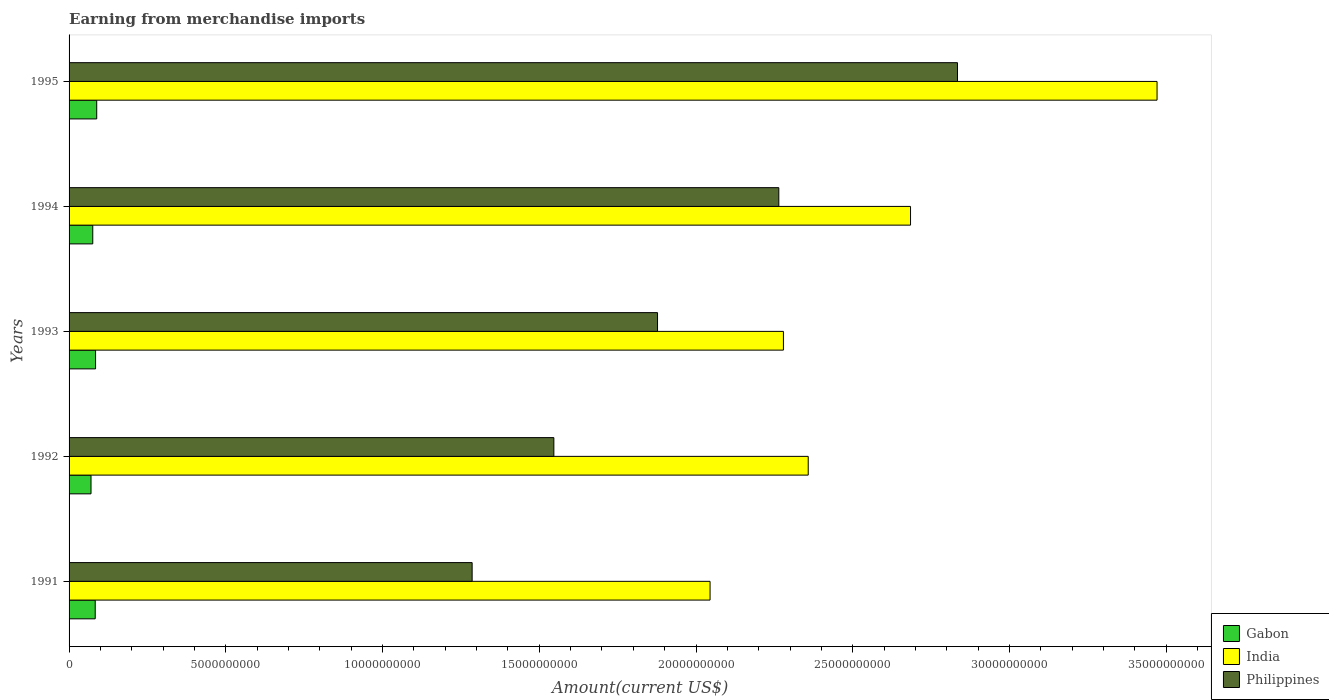How many groups of bars are there?
Your answer should be very brief. 5. Are the number of bars per tick equal to the number of legend labels?
Make the answer very short. Yes. How many bars are there on the 4th tick from the top?
Your answer should be very brief. 3. How many bars are there on the 5th tick from the bottom?
Your answer should be compact. 3. In how many cases, is the number of bars for a given year not equal to the number of legend labels?
Your response must be concise. 0. What is the amount earned from merchandise imports in India in 1992?
Offer a terse response. 2.36e+1. Across all years, what is the maximum amount earned from merchandise imports in Philippines?
Offer a very short reply. 2.83e+1. Across all years, what is the minimum amount earned from merchandise imports in Philippines?
Provide a short and direct response. 1.29e+1. In which year was the amount earned from merchandise imports in Philippines maximum?
Give a very brief answer. 1995. In which year was the amount earned from merchandise imports in India minimum?
Your response must be concise. 1991. What is the total amount earned from merchandise imports in Gabon in the graph?
Provide a short and direct response. 4.02e+09. What is the difference between the amount earned from merchandise imports in Gabon in 1991 and that in 1993?
Offer a very short reply. -1.10e+07. What is the difference between the amount earned from merchandise imports in Philippines in 1994 and the amount earned from merchandise imports in Gabon in 1995?
Your answer should be compact. 2.18e+1. What is the average amount earned from merchandise imports in India per year?
Your response must be concise. 2.57e+1. In the year 1993, what is the difference between the amount earned from merchandise imports in Philippines and amount earned from merchandise imports in India?
Keep it short and to the point. -4.02e+09. What is the ratio of the amount earned from merchandise imports in Philippines in 1994 to that in 1995?
Give a very brief answer. 0.8. Is the amount earned from merchandise imports in Gabon in 1991 less than that in 1992?
Your answer should be compact. No. What is the difference between the highest and the second highest amount earned from merchandise imports in Gabon?
Offer a very short reply. 3.70e+07. What is the difference between the highest and the lowest amount earned from merchandise imports in Gabon?
Your answer should be very brief. 1.82e+08. In how many years, is the amount earned from merchandise imports in India greater than the average amount earned from merchandise imports in India taken over all years?
Your answer should be compact. 2. What does the 1st bar from the bottom in 1993 represents?
Keep it short and to the point. Gabon. How many bars are there?
Give a very brief answer. 15. How many years are there in the graph?
Ensure brevity in your answer.  5. Are the values on the major ticks of X-axis written in scientific E-notation?
Give a very brief answer. No. Does the graph contain grids?
Ensure brevity in your answer.  No. How are the legend labels stacked?
Your answer should be compact. Vertical. What is the title of the graph?
Ensure brevity in your answer.  Earning from merchandise imports. What is the label or title of the X-axis?
Offer a very short reply. Amount(current US$). What is the Amount(current US$) in Gabon in 1991?
Provide a succinct answer. 8.34e+08. What is the Amount(current US$) of India in 1991?
Provide a succinct answer. 2.04e+1. What is the Amount(current US$) of Philippines in 1991?
Offer a terse response. 1.29e+1. What is the Amount(current US$) of Gabon in 1992?
Provide a short and direct response. 7.00e+08. What is the Amount(current US$) in India in 1992?
Keep it short and to the point. 2.36e+1. What is the Amount(current US$) of Philippines in 1992?
Ensure brevity in your answer.  1.55e+1. What is the Amount(current US$) in Gabon in 1993?
Keep it short and to the point. 8.45e+08. What is the Amount(current US$) of India in 1993?
Make the answer very short. 2.28e+1. What is the Amount(current US$) of Philippines in 1993?
Your response must be concise. 1.88e+1. What is the Amount(current US$) of Gabon in 1994?
Give a very brief answer. 7.56e+08. What is the Amount(current US$) of India in 1994?
Offer a terse response. 2.68e+1. What is the Amount(current US$) in Philippines in 1994?
Provide a short and direct response. 2.26e+1. What is the Amount(current US$) in Gabon in 1995?
Ensure brevity in your answer.  8.82e+08. What is the Amount(current US$) of India in 1995?
Provide a short and direct response. 3.47e+1. What is the Amount(current US$) of Philippines in 1995?
Your answer should be very brief. 2.83e+1. Across all years, what is the maximum Amount(current US$) in Gabon?
Keep it short and to the point. 8.82e+08. Across all years, what is the maximum Amount(current US$) in India?
Give a very brief answer. 3.47e+1. Across all years, what is the maximum Amount(current US$) of Philippines?
Your answer should be compact. 2.83e+1. Across all years, what is the minimum Amount(current US$) in Gabon?
Ensure brevity in your answer.  7.00e+08. Across all years, what is the minimum Amount(current US$) in India?
Provide a succinct answer. 2.04e+1. Across all years, what is the minimum Amount(current US$) of Philippines?
Your answer should be compact. 1.29e+1. What is the total Amount(current US$) of Gabon in the graph?
Offer a terse response. 4.02e+09. What is the total Amount(current US$) of India in the graph?
Provide a short and direct response. 1.28e+11. What is the total Amount(current US$) in Philippines in the graph?
Offer a terse response. 9.81e+1. What is the difference between the Amount(current US$) of Gabon in 1991 and that in 1992?
Give a very brief answer. 1.34e+08. What is the difference between the Amount(current US$) of India in 1991 and that in 1992?
Keep it short and to the point. -3.13e+09. What is the difference between the Amount(current US$) of Philippines in 1991 and that in 1992?
Your response must be concise. -2.61e+09. What is the difference between the Amount(current US$) of Gabon in 1991 and that in 1993?
Your answer should be very brief. -1.10e+07. What is the difference between the Amount(current US$) in India in 1991 and that in 1993?
Offer a terse response. -2.34e+09. What is the difference between the Amount(current US$) of Philippines in 1991 and that in 1993?
Your response must be concise. -5.91e+09. What is the difference between the Amount(current US$) of Gabon in 1991 and that in 1994?
Offer a terse response. 7.80e+07. What is the difference between the Amount(current US$) of India in 1991 and that in 1994?
Keep it short and to the point. -6.40e+09. What is the difference between the Amount(current US$) of Philippines in 1991 and that in 1994?
Your answer should be very brief. -9.78e+09. What is the difference between the Amount(current US$) in Gabon in 1991 and that in 1995?
Provide a succinct answer. -4.80e+07. What is the difference between the Amount(current US$) in India in 1991 and that in 1995?
Your answer should be compact. -1.43e+1. What is the difference between the Amount(current US$) of Philippines in 1991 and that in 1995?
Your answer should be compact. -1.55e+1. What is the difference between the Amount(current US$) in Gabon in 1992 and that in 1993?
Your answer should be compact. -1.45e+08. What is the difference between the Amount(current US$) in India in 1992 and that in 1993?
Offer a very short reply. 7.91e+08. What is the difference between the Amount(current US$) of Philippines in 1992 and that in 1993?
Make the answer very short. -3.31e+09. What is the difference between the Amount(current US$) in Gabon in 1992 and that in 1994?
Give a very brief answer. -5.60e+07. What is the difference between the Amount(current US$) in India in 1992 and that in 1994?
Ensure brevity in your answer.  -3.26e+09. What is the difference between the Amount(current US$) of Philippines in 1992 and that in 1994?
Provide a succinct answer. -7.18e+09. What is the difference between the Amount(current US$) of Gabon in 1992 and that in 1995?
Keep it short and to the point. -1.82e+08. What is the difference between the Amount(current US$) of India in 1992 and that in 1995?
Provide a succinct answer. -1.11e+1. What is the difference between the Amount(current US$) in Philippines in 1992 and that in 1995?
Your answer should be very brief. -1.29e+1. What is the difference between the Amount(current US$) in Gabon in 1993 and that in 1994?
Ensure brevity in your answer.  8.90e+07. What is the difference between the Amount(current US$) of India in 1993 and that in 1994?
Offer a terse response. -4.06e+09. What is the difference between the Amount(current US$) of Philippines in 1993 and that in 1994?
Offer a terse response. -3.87e+09. What is the difference between the Amount(current US$) of Gabon in 1993 and that in 1995?
Give a very brief answer. -3.70e+07. What is the difference between the Amount(current US$) in India in 1993 and that in 1995?
Your answer should be compact. -1.19e+1. What is the difference between the Amount(current US$) of Philippines in 1993 and that in 1995?
Offer a terse response. -9.57e+09. What is the difference between the Amount(current US$) in Gabon in 1994 and that in 1995?
Your answer should be very brief. -1.26e+08. What is the difference between the Amount(current US$) of India in 1994 and that in 1995?
Offer a terse response. -7.86e+09. What is the difference between the Amount(current US$) of Philippines in 1994 and that in 1995?
Your answer should be very brief. -5.70e+09. What is the difference between the Amount(current US$) in Gabon in 1991 and the Amount(current US$) in India in 1992?
Your response must be concise. -2.27e+1. What is the difference between the Amount(current US$) in Gabon in 1991 and the Amount(current US$) in Philippines in 1992?
Offer a very short reply. -1.46e+1. What is the difference between the Amount(current US$) in India in 1991 and the Amount(current US$) in Philippines in 1992?
Offer a terse response. 4.98e+09. What is the difference between the Amount(current US$) of Gabon in 1991 and the Amount(current US$) of India in 1993?
Offer a very short reply. -2.20e+1. What is the difference between the Amount(current US$) of Gabon in 1991 and the Amount(current US$) of Philippines in 1993?
Make the answer very short. -1.79e+1. What is the difference between the Amount(current US$) of India in 1991 and the Amount(current US$) of Philippines in 1993?
Provide a succinct answer. 1.68e+09. What is the difference between the Amount(current US$) in Gabon in 1991 and the Amount(current US$) in India in 1994?
Make the answer very short. -2.60e+1. What is the difference between the Amount(current US$) in Gabon in 1991 and the Amount(current US$) in Philippines in 1994?
Make the answer very short. -2.18e+1. What is the difference between the Amount(current US$) in India in 1991 and the Amount(current US$) in Philippines in 1994?
Offer a terse response. -2.19e+09. What is the difference between the Amount(current US$) in Gabon in 1991 and the Amount(current US$) in India in 1995?
Your response must be concise. -3.39e+1. What is the difference between the Amount(current US$) of Gabon in 1991 and the Amount(current US$) of Philippines in 1995?
Your answer should be very brief. -2.75e+1. What is the difference between the Amount(current US$) of India in 1991 and the Amount(current US$) of Philippines in 1995?
Your answer should be very brief. -7.89e+09. What is the difference between the Amount(current US$) of Gabon in 1992 and the Amount(current US$) of India in 1993?
Make the answer very short. -2.21e+1. What is the difference between the Amount(current US$) of Gabon in 1992 and the Amount(current US$) of Philippines in 1993?
Provide a succinct answer. -1.81e+1. What is the difference between the Amount(current US$) of India in 1992 and the Amount(current US$) of Philippines in 1993?
Ensure brevity in your answer.  4.81e+09. What is the difference between the Amount(current US$) of Gabon in 1992 and the Amount(current US$) of India in 1994?
Your answer should be compact. -2.61e+1. What is the difference between the Amount(current US$) in Gabon in 1992 and the Amount(current US$) in Philippines in 1994?
Your answer should be very brief. -2.19e+1. What is the difference between the Amount(current US$) in India in 1992 and the Amount(current US$) in Philippines in 1994?
Offer a very short reply. 9.38e+08. What is the difference between the Amount(current US$) of Gabon in 1992 and the Amount(current US$) of India in 1995?
Your response must be concise. -3.40e+1. What is the difference between the Amount(current US$) of Gabon in 1992 and the Amount(current US$) of Philippines in 1995?
Offer a terse response. -2.76e+1. What is the difference between the Amount(current US$) of India in 1992 and the Amount(current US$) of Philippines in 1995?
Provide a succinct answer. -4.76e+09. What is the difference between the Amount(current US$) of Gabon in 1993 and the Amount(current US$) of India in 1994?
Offer a very short reply. -2.60e+1. What is the difference between the Amount(current US$) of Gabon in 1993 and the Amount(current US$) of Philippines in 1994?
Give a very brief answer. -2.18e+1. What is the difference between the Amount(current US$) in India in 1993 and the Amount(current US$) in Philippines in 1994?
Make the answer very short. 1.47e+08. What is the difference between the Amount(current US$) of Gabon in 1993 and the Amount(current US$) of India in 1995?
Provide a short and direct response. -3.39e+1. What is the difference between the Amount(current US$) of Gabon in 1993 and the Amount(current US$) of Philippines in 1995?
Ensure brevity in your answer.  -2.75e+1. What is the difference between the Amount(current US$) of India in 1993 and the Amount(current US$) of Philippines in 1995?
Your response must be concise. -5.55e+09. What is the difference between the Amount(current US$) of Gabon in 1994 and the Amount(current US$) of India in 1995?
Provide a succinct answer. -3.40e+1. What is the difference between the Amount(current US$) of Gabon in 1994 and the Amount(current US$) of Philippines in 1995?
Keep it short and to the point. -2.76e+1. What is the difference between the Amount(current US$) of India in 1994 and the Amount(current US$) of Philippines in 1995?
Your response must be concise. -1.50e+09. What is the average Amount(current US$) of Gabon per year?
Ensure brevity in your answer.  8.03e+08. What is the average Amount(current US$) in India per year?
Provide a short and direct response. 2.57e+1. What is the average Amount(current US$) in Philippines per year?
Provide a short and direct response. 1.96e+1. In the year 1991, what is the difference between the Amount(current US$) in Gabon and Amount(current US$) in India?
Your answer should be very brief. -1.96e+1. In the year 1991, what is the difference between the Amount(current US$) of Gabon and Amount(current US$) of Philippines?
Your answer should be very brief. -1.20e+1. In the year 1991, what is the difference between the Amount(current US$) of India and Amount(current US$) of Philippines?
Offer a very short reply. 7.59e+09. In the year 1992, what is the difference between the Amount(current US$) in Gabon and Amount(current US$) in India?
Your response must be concise. -2.29e+1. In the year 1992, what is the difference between the Amount(current US$) of Gabon and Amount(current US$) of Philippines?
Give a very brief answer. -1.48e+1. In the year 1992, what is the difference between the Amount(current US$) in India and Amount(current US$) in Philippines?
Ensure brevity in your answer.  8.11e+09. In the year 1993, what is the difference between the Amount(current US$) of Gabon and Amount(current US$) of India?
Offer a very short reply. -2.19e+1. In the year 1993, what is the difference between the Amount(current US$) of Gabon and Amount(current US$) of Philippines?
Offer a very short reply. -1.79e+1. In the year 1993, what is the difference between the Amount(current US$) of India and Amount(current US$) of Philippines?
Your answer should be very brief. 4.02e+09. In the year 1994, what is the difference between the Amount(current US$) of Gabon and Amount(current US$) of India?
Ensure brevity in your answer.  -2.61e+1. In the year 1994, what is the difference between the Amount(current US$) of Gabon and Amount(current US$) of Philippines?
Ensure brevity in your answer.  -2.19e+1. In the year 1994, what is the difference between the Amount(current US$) in India and Amount(current US$) in Philippines?
Keep it short and to the point. 4.20e+09. In the year 1995, what is the difference between the Amount(current US$) of Gabon and Amount(current US$) of India?
Your response must be concise. -3.38e+1. In the year 1995, what is the difference between the Amount(current US$) of Gabon and Amount(current US$) of Philippines?
Provide a succinct answer. -2.75e+1. In the year 1995, what is the difference between the Amount(current US$) of India and Amount(current US$) of Philippines?
Your answer should be compact. 6.37e+09. What is the ratio of the Amount(current US$) of Gabon in 1991 to that in 1992?
Give a very brief answer. 1.19. What is the ratio of the Amount(current US$) in India in 1991 to that in 1992?
Your answer should be very brief. 0.87. What is the ratio of the Amount(current US$) of Philippines in 1991 to that in 1992?
Your response must be concise. 0.83. What is the ratio of the Amount(current US$) of India in 1991 to that in 1993?
Give a very brief answer. 0.9. What is the ratio of the Amount(current US$) in Philippines in 1991 to that in 1993?
Ensure brevity in your answer.  0.69. What is the ratio of the Amount(current US$) in Gabon in 1991 to that in 1994?
Provide a succinct answer. 1.1. What is the ratio of the Amount(current US$) in India in 1991 to that in 1994?
Give a very brief answer. 0.76. What is the ratio of the Amount(current US$) in Philippines in 1991 to that in 1994?
Keep it short and to the point. 0.57. What is the ratio of the Amount(current US$) of Gabon in 1991 to that in 1995?
Give a very brief answer. 0.95. What is the ratio of the Amount(current US$) in India in 1991 to that in 1995?
Ensure brevity in your answer.  0.59. What is the ratio of the Amount(current US$) of Philippines in 1991 to that in 1995?
Provide a succinct answer. 0.45. What is the ratio of the Amount(current US$) of Gabon in 1992 to that in 1993?
Provide a succinct answer. 0.83. What is the ratio of the Amount(current US$) in India in 1992 to that in 1993?
Offer a terse response. 1.03. What is the ratio of the Amount(current US$) of Philippines in 1992 to that in 1993?
Keep it short and to the point. 0.82. What is the ratio of the Amount(current US$) of Gabon in 1992 to that in 1994?
Offer a very short reply. 0.93. What is the ratio of the Amount(current US$) in India in 1992 to that in 1994?
Offer a very short reply. 0.88. What is the ratio of the Amount(current US$) in Philippines in 1992 to that in 1994?
Offer a very short reply. 0.68. What is the ratio of the Amount(current US$) in Gabon in 1992 to that in 1995?
Offer a very short reply. 0.79. What is the ratio of the Amount(current US$) of India in 1992 to that in 1995?
Your answer should be very brief. 0.68. What is the ratio of the Amount(current US$) of Philippines in 1992 to that in 1995?
Offer a terse response. 0.55. What is the ratio of the Amount(current US$) in Gabon in 1993 to that in 1994?
Provide a succinct answer. 1.12. What is the ratio of the Amount(current US$) in India in 1993 to that in 1994?
Provide a short and direct response. 0.85. What is the ratio of the Amount(current US$) in Philippines in 1993 to that in 1994?
Provide a succinct answer. 0.83. What is the ratio of the Amount(current US$) in Gabon in 1993 to that in 1995?
Offer a very short reply. 0.96. What is the ratio of the Amount(current US$) of India in 1993 to that in 1995?
Provide a short and direct response. 0.66. What is the ratio of the Amount(current US$) of Philippines in 1993 to that in 1995?
Your answer should be compact. 0.66. What is the ratio of the Amount(current US$) in India in 1994 to that in 1995?
Provide a succinct answer. 0.77. What is the ratio of the Amount(current US$) of Philippines in 1994 to that in 1995?
Offer a very short reply. 0.8. What is the difference between the highest and the second highest Amount(current US$) in Gabon?
Keep it short and to the point. 3.70e+07. What is the difference between the highest and the second highest Amount(current US$) in India?
Your answer should be very brief. 7.86e+09. What is the difference between the highest and the second highest Amount(current US$) in Philippines?
Offer a very short reply. 5.70e+09. What is the difference between the highest and the lowest Amount(current US$) of Gabon?
Make the answer very short. 1.82e+08. What is the difference between the highest and the lowest Amount(current US$) in India?
Your response must be concise. 1.43e+1. What is the difference between the highest and the lowest Amount(current US$) of Philippines?
Offer a very short reply. 1.55e+1. 